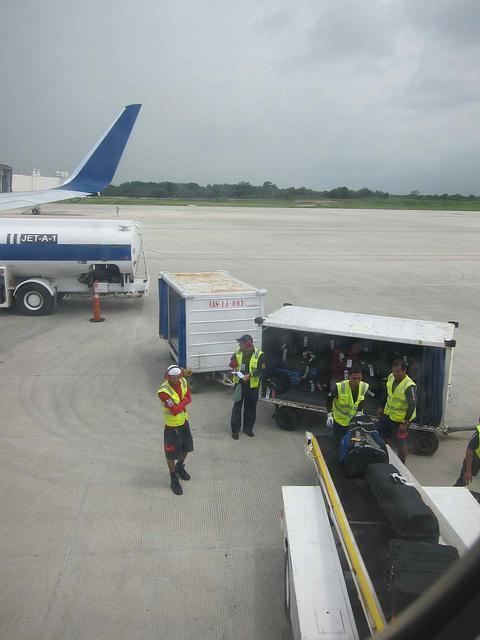What are they doing with the luggage?
Make your selection from the four choices given to correctly answer the question.
Options: Unloading, selling, stealing, loading. Unloading. 